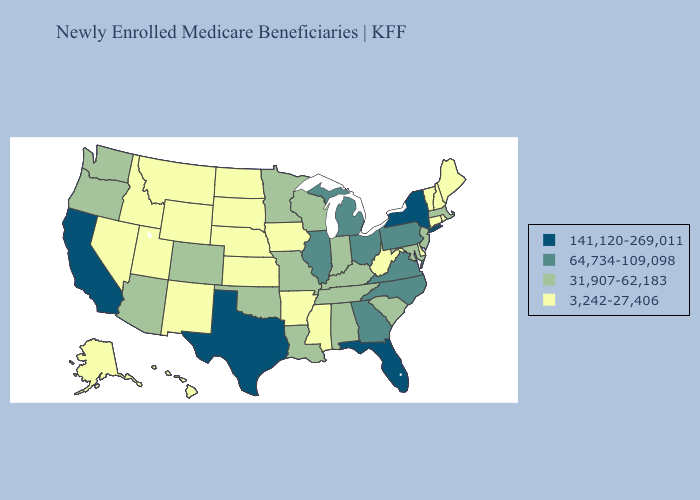What is the value of Wisconsin?
Write a very short answer. 31,907-62,183. Which states have the lowest value in the Northeast?
Give a very brief answer. Connecticut, Maine, New Hampshire, Rhode Island, Vermont. Does New Jersey have the lowest value in the USA?
Keep it brief. No. Name the states that have a value in the range 31,907-62,183?
Answer briefly. Alabama, Arizona, Colorado, Indiana, Kentucky, Louisiana, Maryland, Massachusetts, Minnesota, Missouri, New Jersey, Oklahoma, Oregon, South Carolina, Tennessee, Washington, Wisconsin. Among the states that border Virginia , which have the lowest value?
Answer briefly. West Virginia. What is the value of Colorado?
Write a very short answer. 31,907-62,183. Does Louisiana have a higher value than Utah?
Answer briefly. Yes. What is the value of South Dakota?
Answer briefly. 3,242-27,406. Does the first symbol in the legend represent the smallest category?
Quick response, please. No. What is the value of Hawaii?
Answer briefly. 3,242-27,406. Among the states that border Mississippi , does Arkansas have the lowest value?
Keep it brief. Yes. Name the states that have a value in the range 3,242-27,406?
Be succinct. Alaska, Arkansas, Connecticut, Delaware, Hawaii, Idaho, Iowa, Kansas, Maine, Mississippi, Montana, Nebraska, Nevada, New Hampshire, New Mexico, North Dakota, Rhode Island, South Dakota, Utah, Vermont, West Virginia, Wyoming. Does the map have missing data?
Quick response, please. No. What is the value of Indiana?
Be succinct. 31,907-62,183. Among the states that border New Hampshire , which have the lowest value?
Be succinct. Maine, Vermont. 